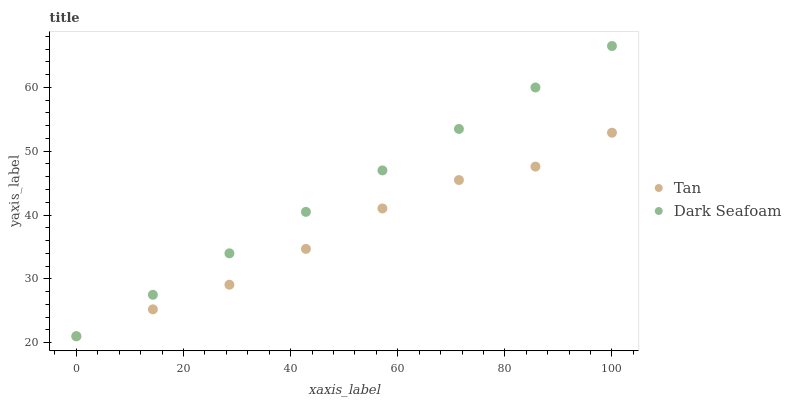Does Tan have the minimum area under the curve?
Answer yes or no. Yes. Does Dark Seafoam have the maximum area under the curve?
Answer yes or no. Yes. Does Dark Seafoam have the minimum area under the curve?
Answer yes or no. No. Is Dark Seafoam the smoothest?
Answer yes or no. Yes. Is Tan the roughest?
Answer yes or no. Yes. Is Dark Seafoam the roughest?
Answer yes or no. No. Does Tan have the lowest value?
Answer yes or no. Yes. Does Dark Seafoam have the highest value?
Answer yes or no. Yes. Does Tan intersect Dark Seafoam?
Answer yes or no. Yes. Is Tan less than Dark Seafoam?
Answer yes or no. No. Is Tan greater than Dark Seafoam?
Answer yes or no. No. 